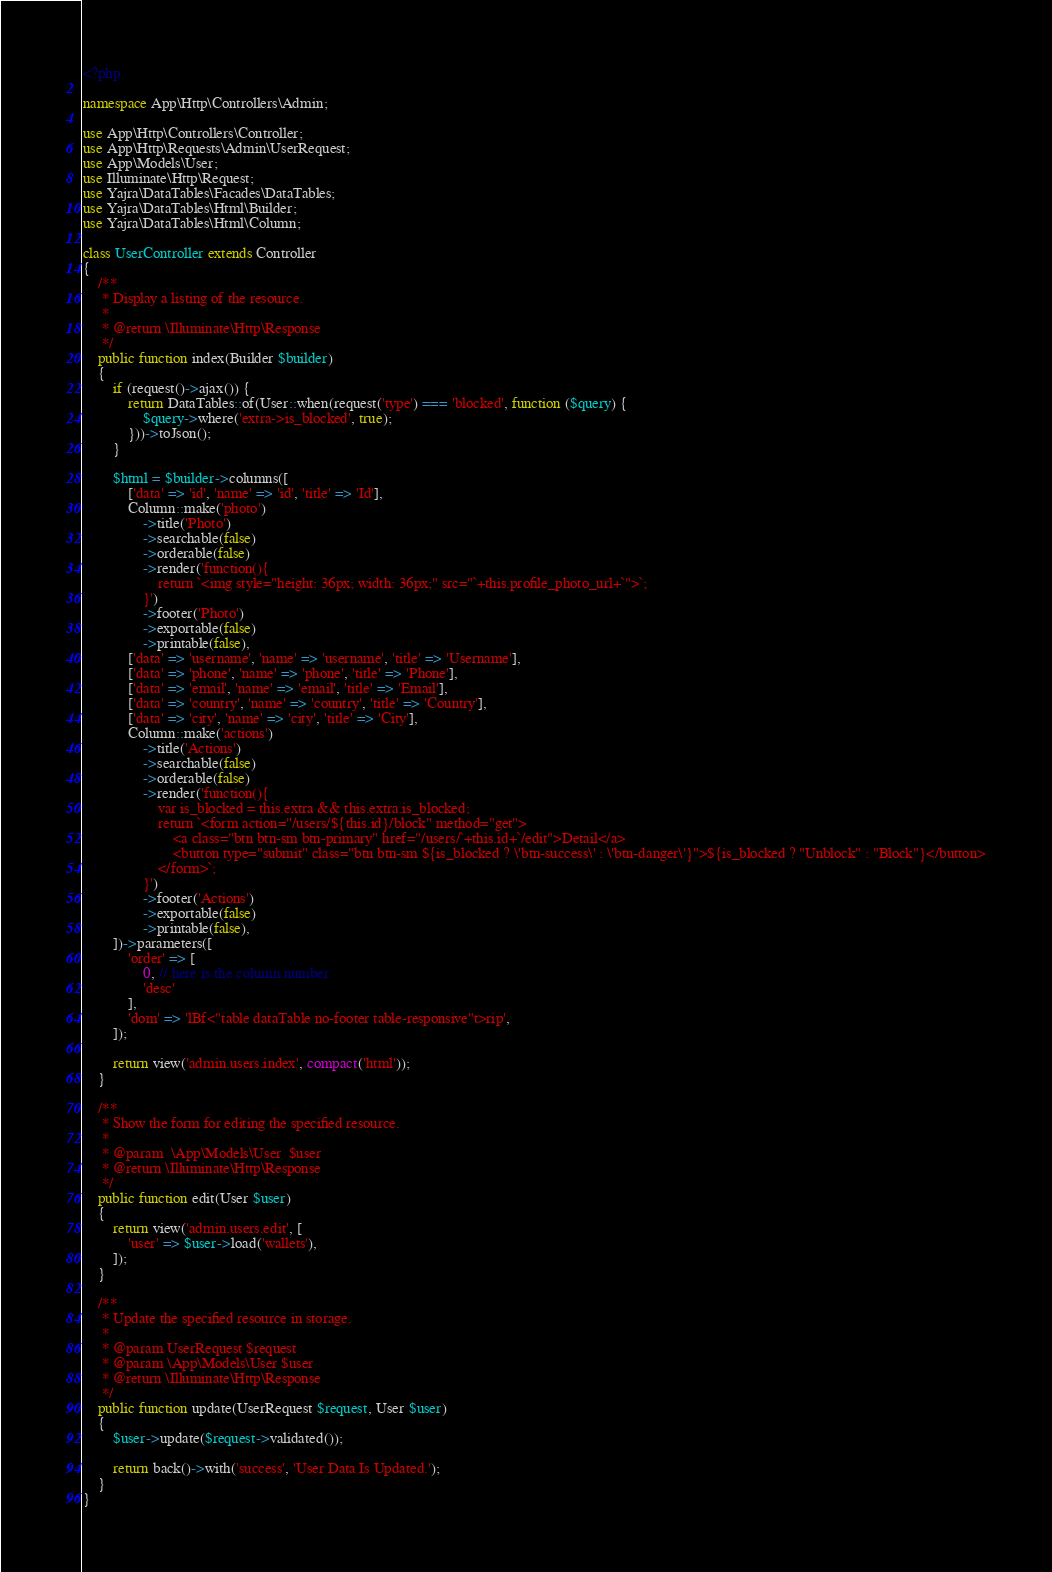<code> <loc_0><loc_0><loc_500><loc_500><_PHP_><?php

namespace App\Http\Controllers\Admin;

use App\Http\Controllers\Controller;
use App\Http\Requests\Admin\UserRequest;
use App\Models\User;
use Illuminate\Http\Request;
use Yajra\DataTables\Facades\DataTables;
use Yajra\DataTables\Html\Builder;
use Yajra\DataTables\Html\Column;

class UserController extends Controller
{
    /**
     * Display a listing of the resource.
     *
     * @return \Illuminate\Http\Response
     */
    public function index(Builder $builder)
    {
        if (request()->ajax()) {
            return DataTables::of(User::when(request('type') === 'blocked', function ($query) {
                $query->where('extra->is_blocked', true);
            }))->toJson();
        }

        $html = $builder->columns([
            ['data' => 'id', 'name' => 'id', 'title' => 'Id'],
            Column::make('photo')
                ->title('Photo')
                ->searchable(false)
                ->orderable(false)
                ->render('function(){
                    return `<img style="height: 36px; width: 36px;" src="`+this.profile_photo_url+`">`;
                }')
                ->footer('Photo')
                ->exportable(false)
                ->printable(false),
            ['data' => 'username', 'name' => 'username', 'title' => 'Username'],
            ['data' => 'phone', 'name' => 'phone', 'title' => 'Phone'],
            ['data' => 'email', 'name' => 'email', 'title' => 'Email'],
            ['data' => 'country', 'name' => 'country', 'title' => 'Country'],
            ['data' => 'city', 'name' => 'city', 'title' => 'City'],
            Column::make('actions')
                ->title('Actions')
                ->searchable(false)
                ->orderable(false)
                ->render('function(){
                    var is_blocked = this.extra && this.extra.is_blocked;
                    return `<form action="/users/${this.id}/block" method="get">
                        <a class="btn btn-sm btn-primary" href="/users/`+this.id+`/edit">Detail</a>
                        <button type="submit" class="btn btn-sm ${is_blocked ? \'btn-success\' : \'btn-danger\'}">${is_blocked ? "Unblock" : "Block"}</button>
                    </form>`;
                }')
                ->footer('Actions')
                ->exportable(false)
                ->printable(false),
        ])->parameters([
            'order' => [
                0, // here is the column number
                'desc'
            ],
            'dom' => 'lBf<"table dataTable no-footer table-responsive"t>rip',
        ]);

        return view('admin.users.index', compact('html'));
    }

    /**
     * Show the form for editing the specified resource.
     *
     * @param  \App\Models\User  $user
     * @return \Illuminate\Http\Response
     */
    public function edit(User $user)
    {
        return view('admin.users.edit', [
            'user' => $user->load('wallets'),
        ]);
    }

    /**
     * Update the specified resource in storage.
     *
     * @param UserRequest $request
     * @param \App\Models\User $user
     * @return \Illuminate\Http\Response
     */
    public function update(UserRequest $request, User $user)
    {
        $user->update($request->validated());

        return back()->with('success', 'User Data Is Updated.');
    }
}
</code> 